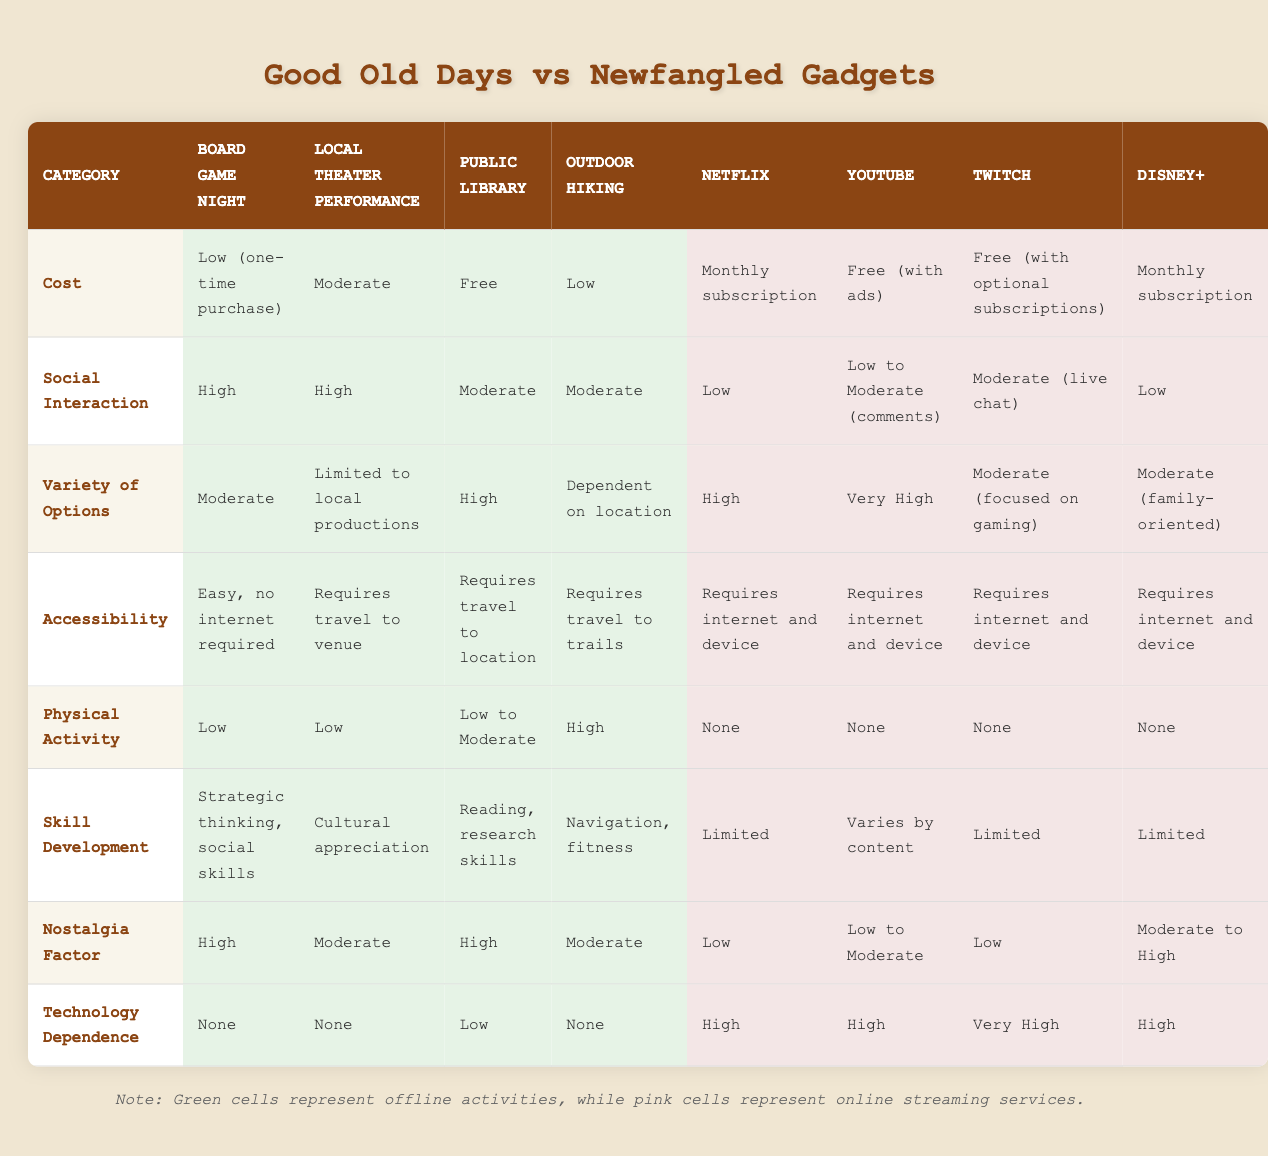What is the cost of attending a Local Theater Performance? According to the table, the cost for a Local Theater Performance is categorized as "Moderate."
Answer: Moderate Which offline option has the highest nostalgia factor? The "Board Game Night" and "Public Library" both have a nostalgia factor categorized as "High," making them the offline options with the highest value in this category.
Answer: Board Game Night, Public Library Does Netflix require any technology dependence? Yes, the table indicates that Netflix has a technology dependence classified as "High," meaning access to technology is needed to use the service.
Answer: Yes How many offline options offer high social interaction? The table lists two offline options—"Board Game Night" and "Local Theater Performance"—with a social interaction rating of "High."
Answer: 2 Which option—outdoor hiking or public library—provides more variety of options? The Outdoor Hiking option provides a variety categorized as "Dependent on location," while the Public Library has a "High" variety of options. Since "High" is greater than "Dependent on location," the Public Library offers more variety.
Answer: Public Library Is the physical activity level higher for offline options compared to online streaming services? Yes, all offline options show varying levels of physical activity, with one option ("Outdoor Hiking") rated as "High." All online streaming options are rated as "None" for physical activity.
Answer: Yes What is the average cost of online streaming services? The costs are: "Monthly subscription" for Netflix and Disney+, "Free (with ads)" for YouTube, and "Free (with optional subscriptions)" for Twitch. Summing these costs (interpreting free as 0) results in a total of 2. The average cost is therefore 2/4 = 0.5. Hence, in the context of these categories, the average cost of online streaming services is "Low."
Answer: Low Which offline entertainment option combines high skill development with physical activity? The only offline option that offers both high skill development and physical activity is "Outdoor Hiking," which is rated "High" for physical activity and "Navigation, fitness" for skill development.
Answer: Outdoor Hiking How does the accessibility of online streaming services compare to offline options? Online streaming services require an internet connection and a device, while offline options mainly require physical travel to locations. Thus, online options present a higher barrier to accessibility than most offline options, which have easier access provisions.
Answer: Online services are less accessible 